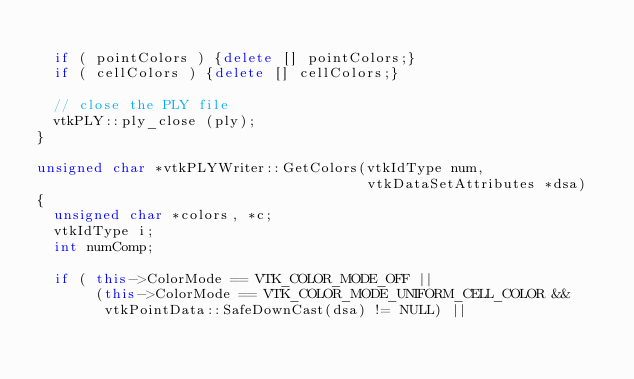Convert code to text. <code><loc_0><loc_0><loc_500><loc_500><_C++_>
  if ( pointColors ) {delete [] pointColors;}
  if ( cellColors ) {delete [] cellColors;}

  // close the PLY file
  vtkPLY::ply_close (ply);
}
  
unsigned char *vtkPLYWriter::GetColors(vtkIdType num,
                                       vtkDataSetAttributes *dsa)
{
  unsigned char *colors, *c;
  vtkIdType i;
  int numComp;

  if ( this->ColorMode == VTK_COLOR_MODE_OFF ||
       (this->ColorMode == VTK_COLOR_MODE_UNIFORM_CELL_COLOR &&
        vtkPointData::SafeDownCast(dsa) != NULL) ||</code> 